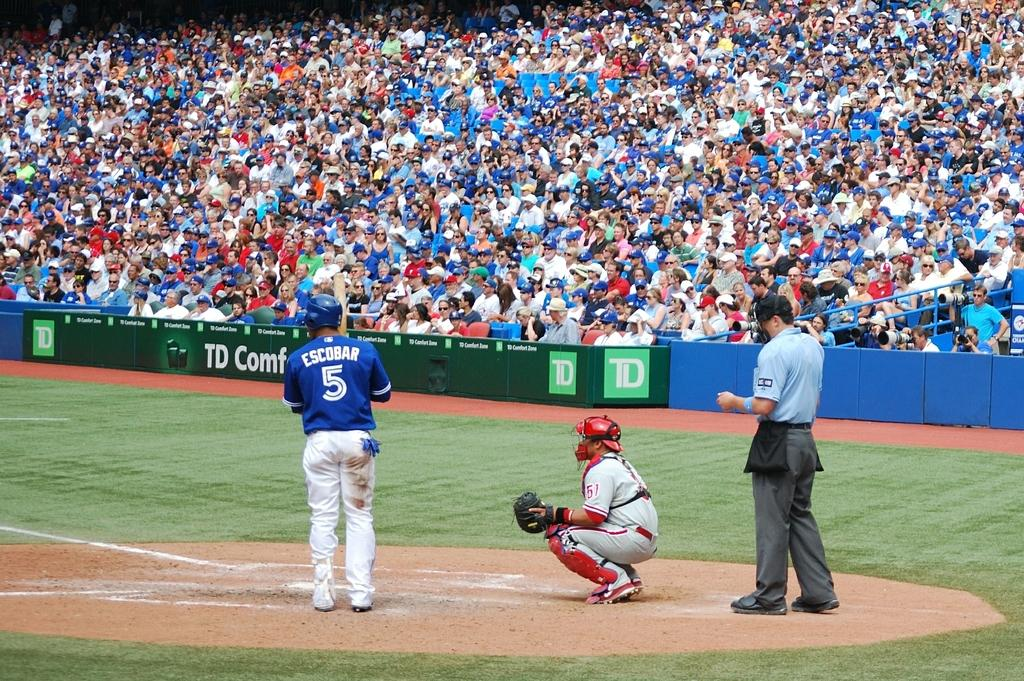<image>
Describe the image concisely. The player in blue wears the number 5 top. 